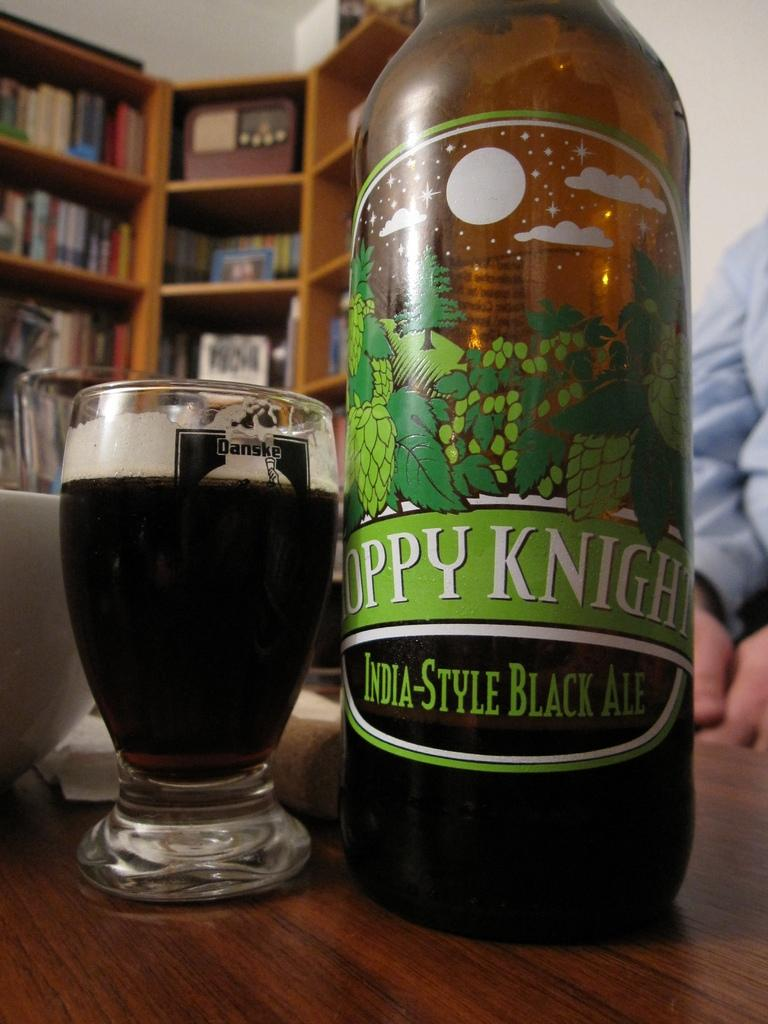<image>
Relay a brief, clear account of the picture shown. A bottle of India style black ale is next to a glass. 